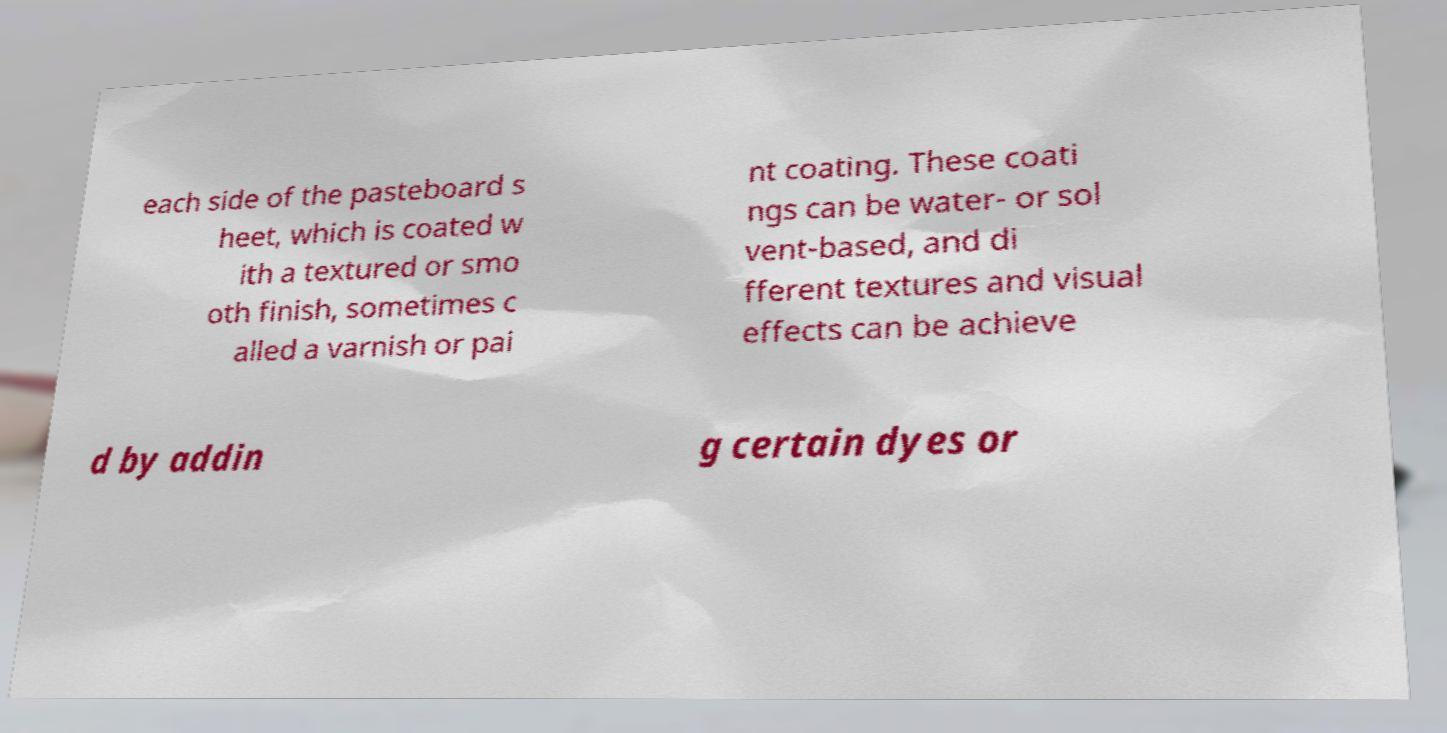I need the written content from this picture converted into text. Can you do that? each side of the pasteboard s heet, which is coated w ith a textured or smo oth finish, sometimes c alled a varnish or pai nt coating. These coati ngs can be water- or sol vent-based, and di fferent textures and visual effects can be achieve d by addin g certain dyes or 